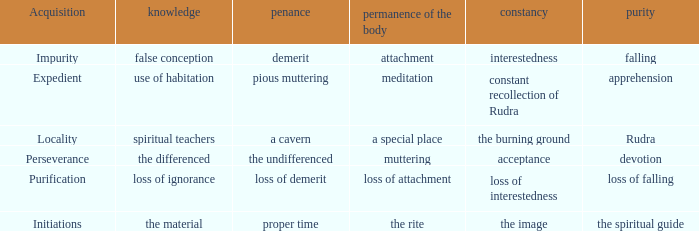 what's the permanence of the body where purity is rudra A special place. 